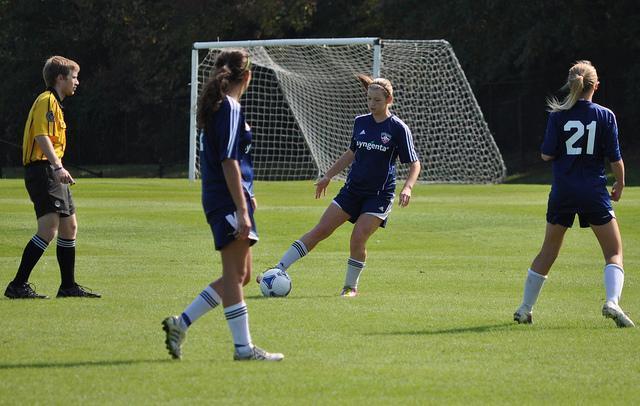How many people are pictured?
Give a very brief answer. 4. How many people are in the photo?
Give a very brief answer. 4. How many people are in the picture?
Give a very brief answer. 4. 